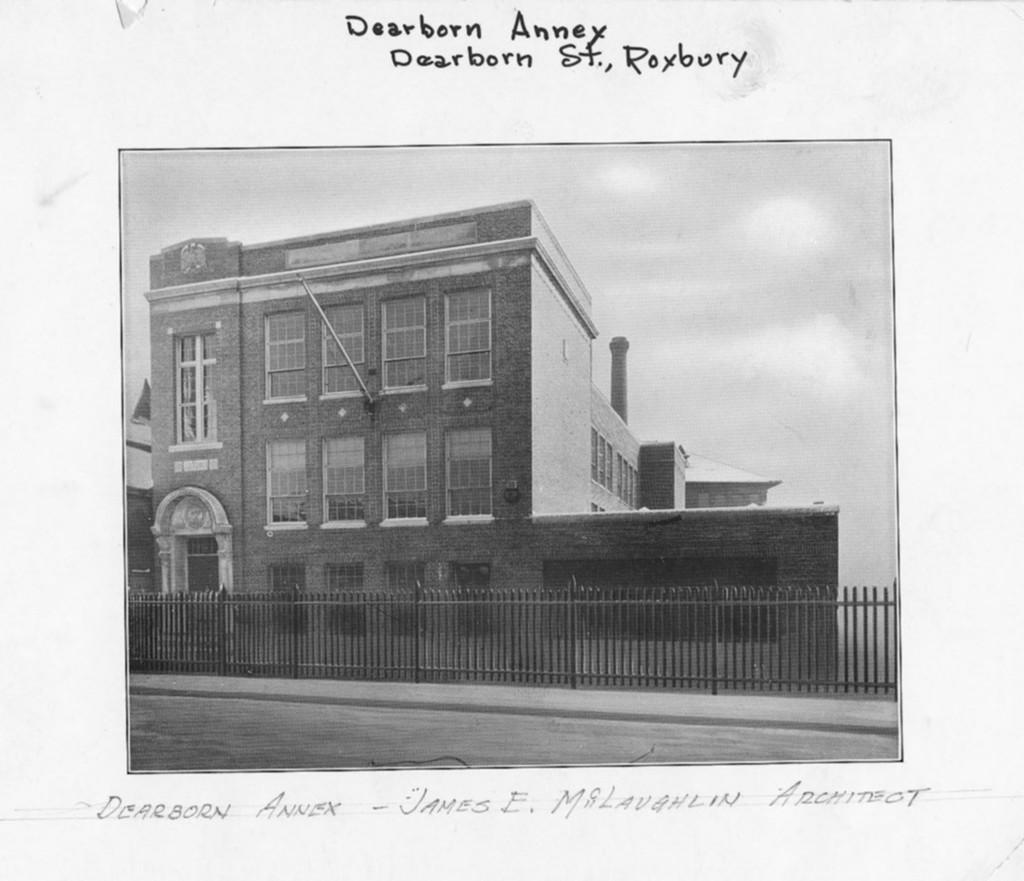What is the main subject of the paper in the image? The paper contains a depiction of the sky, clouds, a building, a wall, windows, a fence, and a road. What elements of the paper's design can be observed? The paper contains a depiction of the sky, clouds, a building, a wall, windows, a fence, and a road. Is there any text on the paper? Yes, there is something written on the paper. What type of alarm is depicted on the paper? There is no alarm depicted on the paper; it contains a depiction of the sky, clouds, a building, a wall, windows, a fence, and a road. How does the artist express regret in the paper's design? There is no expression of regret in the paper's design; it contains a depiction of the sky, clouds, a building, a wall, windows, a fence, and a road, along with some written text. 